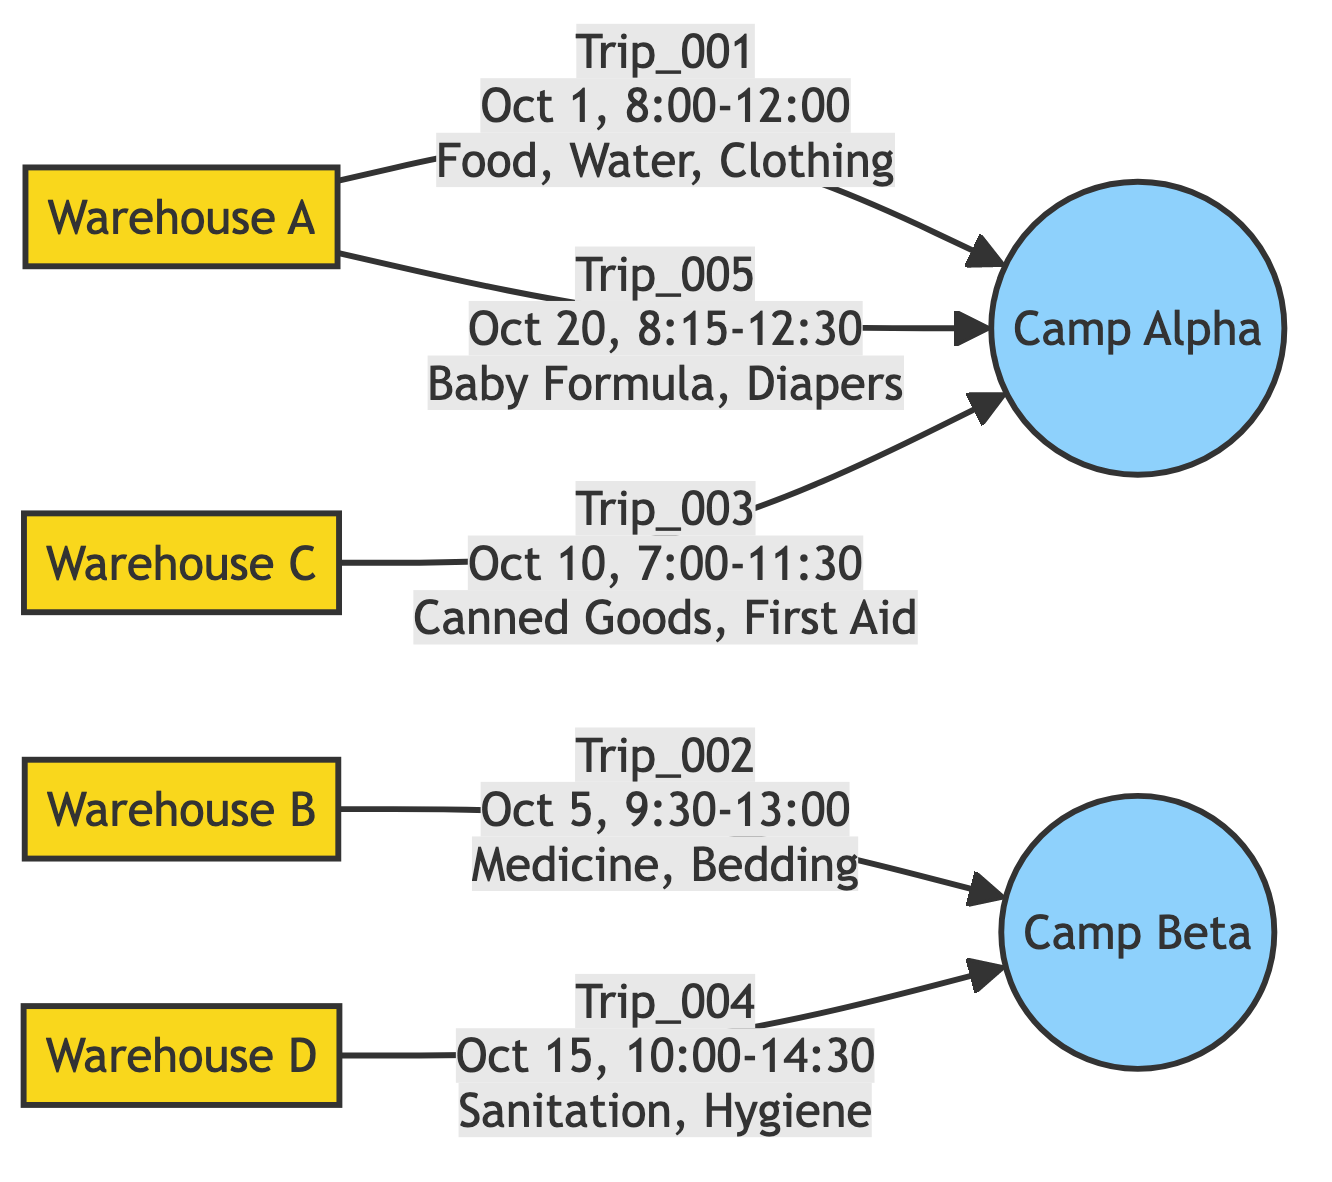What is the total number of trips shown in the diagram? The diagram shows five distinct trip lines leading from warehouses to refugee camps, which indicates that there are five trips in total.
Answer: 5 What is the start location of Trip_003? The diagram labels the starting node for Trip_003 as Warehouse C, indicating that this is where the trip began.
Answer: Warehouse C What supplies were delivered in Trip_001? By referencing the edge from Warehouse A to Camp Alpha, the diagram specifies that Trip_001 delivered Food, Water, and Clothing.
Answer: Food, Water, Clothing Which warehouse has the most trips originating from it? By analyzing the departure nodes, I can see that Warehouse A is connected to two trips (Trip_001 and Trip_005), more than any other warehouse.
Answer: Warehouse A What is the arrival time of Trip_002? Looking at the edge from Warehouse B to Camp Beta, the diagram provides the arrival time for Trip_002 as 13:00 on October 5th.
Answer: 13:00 Which camp received supplies from Trip_004? The arrow leading from Warehouse D points towards Camp Beta, indicating that this is the camp that received supplies from Trip_004.
Answer: Camp Beta What is the relationship between Warehouse C and Camp Alpha? There is a directed edge from Warehouse C to Camp Alpha which signifies that there was a delivery, specifically Trip_003 from Warehouse C to Camp Alpha.
Answer: Trip_003 Which trip did the earliest departure? By reviewing the departure times listed on the edges, Trip_001 which departed at 08:00 on October 1st is the earliest trip among all.
Answer: Trip_001 How many different types of supplies were delivered to Camp Alpha? By observing the edges leading to Camp Alpha (from Trips 001, 003, and 005), the supplies include Food, Water, Clothing, Canned Goods, First Aid Kits, Baby Formula, and Diapers; totaling seven different supplies.
Answer: 7 